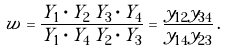<formula> <loc_0><loc_0><loc_500><loc_500>w = \frac { Y _ { 1 } \cdot Y _ { 2 } \, Y _ { 3 } \cdot Y _ { 4 } } { Y _ { 1 } \cdot Y _ { 4 } \, Y _ { 2 } \cdot Y _ { 3 } } = \frac { y _ { 1 2 } y _ { 3 4 } } { y _ { 1 4 } y _ { 2 3 } } \, .</formula> 